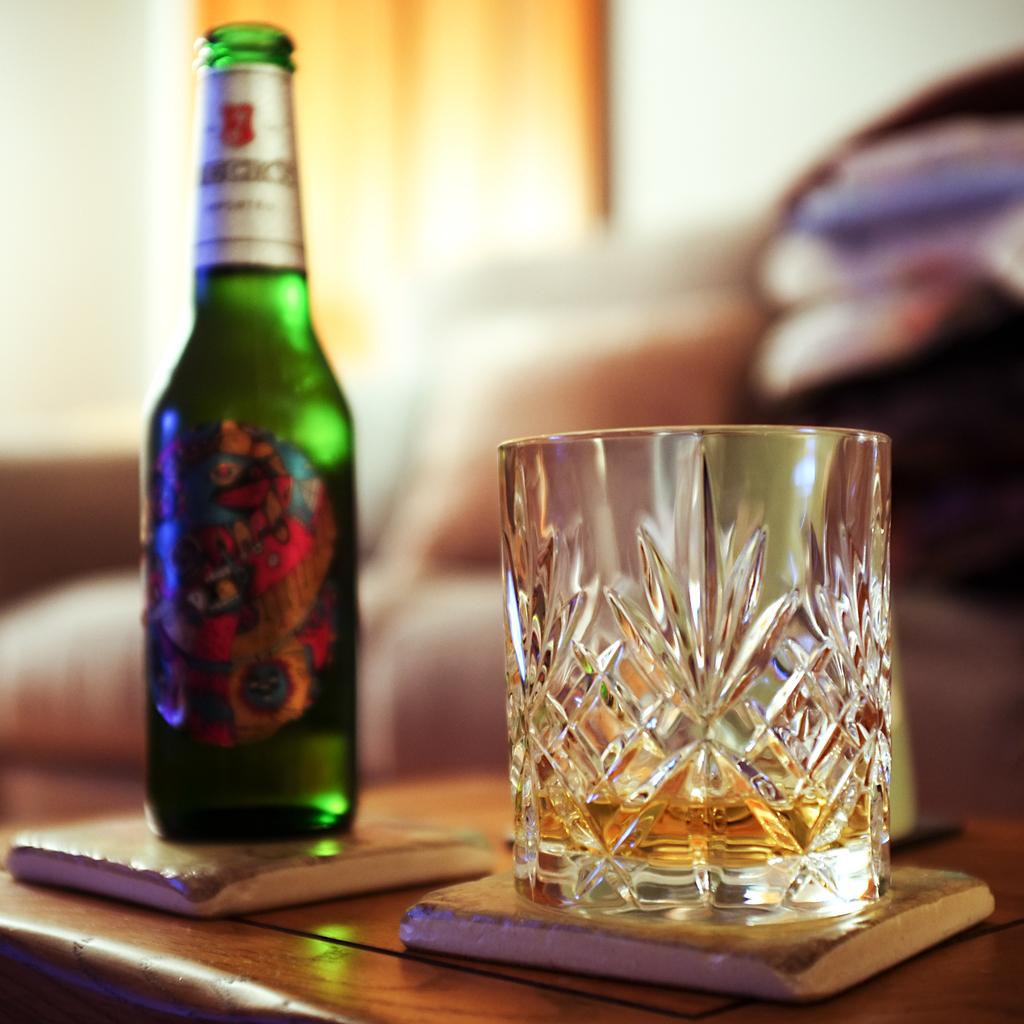What type of drink is this?
Keep it short and to the point. Beer. 